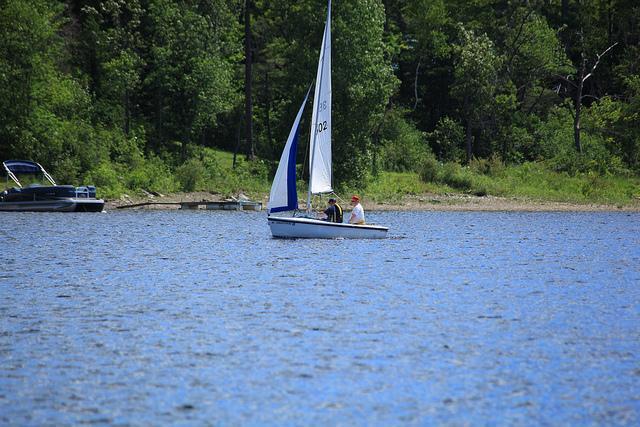How many boats are in the photo?
Give a very brief answer. 2. How many dogs are following the horse?
Give a very brief answer. 0. 